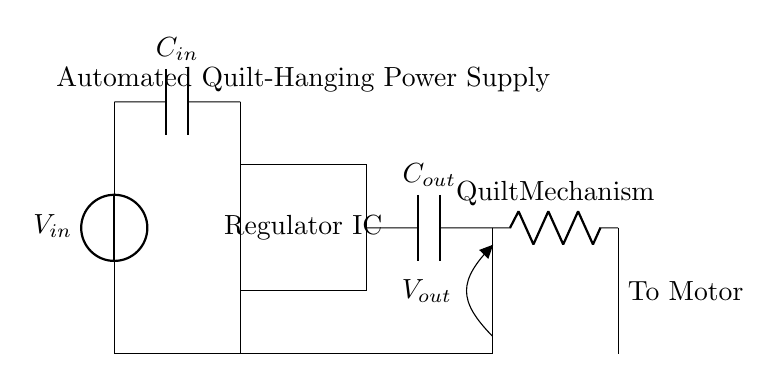What is the input voltage of the circuit? The input voltage is denoted as Vin, which is the voltage source described in the circuit diagram.
Answer: Vin What type of component is the regulator? The regulator is represented as a rectangle labeled "Regulator IC," indicating it is an integrated circuit designed for regulating voltage.
Answer: Integrated Circuit What is the role of the capacitor labeled Cout? The capacitor Cout is connected to the output of the regulator and is used to smooth the output voltage by filtering out noise.
Answer: Smoothing What is connected to the output of the regulator? The output of the regulator connects to Cout and subsequently to the quilt mechanism, which requires power to operate.
Answer: Quilt Mechanism How many capacitors are included in the circuit? The circuit includes two capacitors, Cin and Cout, responsible for stabilizing the input and output voltage, respectively.
Answer: Two Why is a voltage regulator used in this circuit? A voltage regulator stabilizes the output voltage to ensure consistent power delivery to the quilt-hanging mechanism, regardless of fluctuations in input voltage or load changes.
Answer: Consistency What is the output voltage labeled in the circuit? The output voltage is indicated as Vout, representing the regulated voltage supplied to the load.
Answer: Vout 